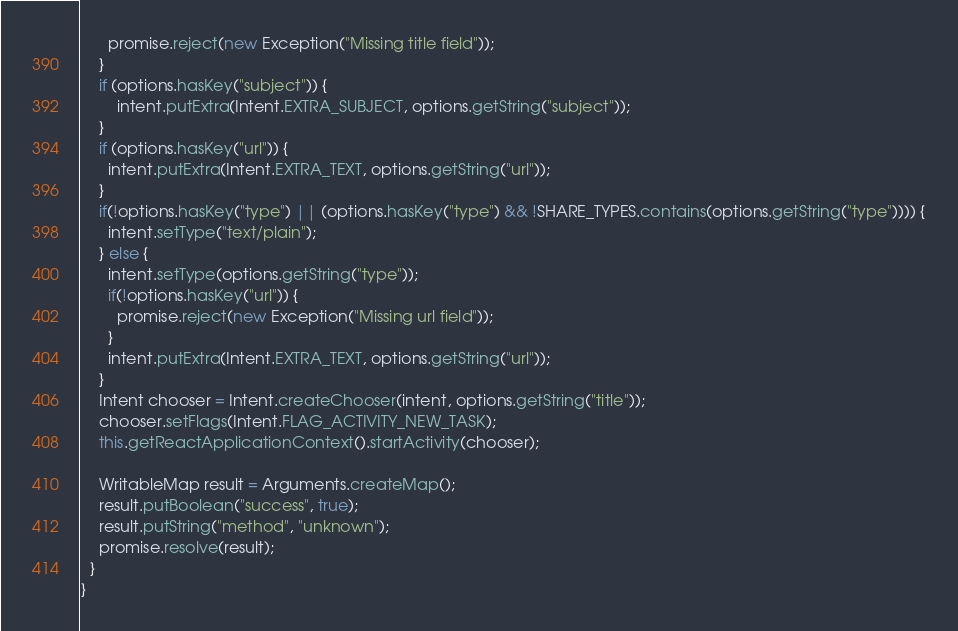Convert code to text. <code><loc_0><loc_0><loc_500><loc_500><_Java_>      promise.reject(new Exception("Missing title field"));
    }
    if (options.hasKey("subject")) {
        intent.putExtra(Intent.EXTRA_SUBJECT, options.getString("subject"));
    }
    if (options.hasKey("url")) {
      intent.putExtra(Intent.EXTRA_TEXT, options.getString("url"));
    }
    if(!options.hasKey("type") || (options.hasKey("type") && !SHARE_TYPES.contains(options.getString("type")))) {
      intent.setType("text/plain");
    } else {
      intent.setType(options.getString("type"));
      if(!options.hasKey("url")) {
        promise.reject(new Exception("Missing url field"));
      }
      intent.putExtra(Intent.EXTRA_TEXT, options.getString("url"));
    }
    Intent chooser = Intent.createChooser(intent, options.getString("title"));
    chooser.setFlags(Intent.FLAG_ACTIVITY_NEW_TASK);
    this.getReactApplicationContext().startActivity(chooser);

    WritableMap result = Arguments.createMap();
    result.putBoolean("success", true);
    result.putString("method", "unknown");
    promise.resolve(result);
  }
}</code> 